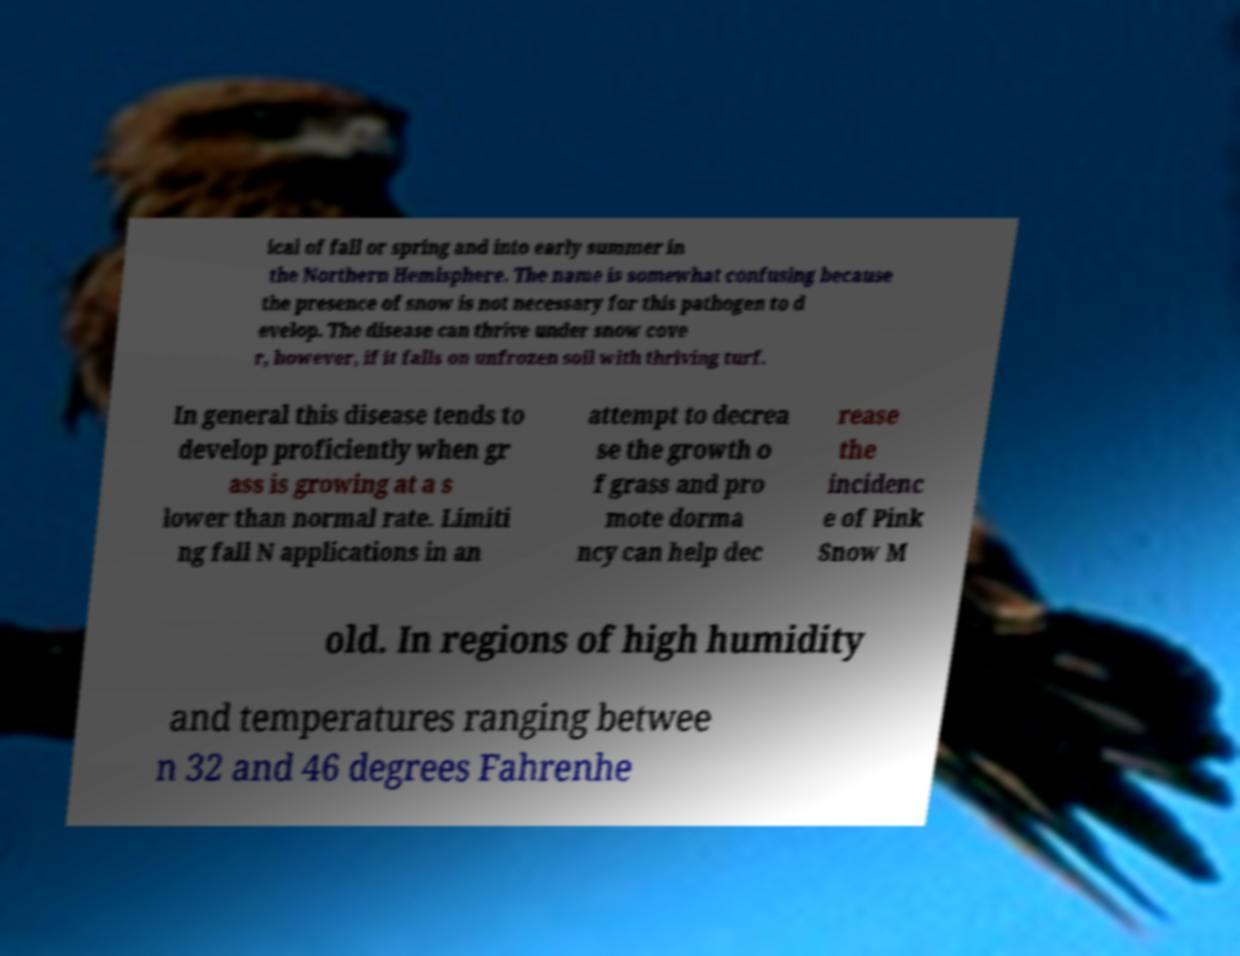There's text embedded in this image that I need extracted. Can you transcribe it verbatim? ical of fall or spring and into early summer in the Northern Hemisphere. The name is somewhat confusing because the presence of snow is not necessary for this pathogen to d evelop. The disease can thrive under snow cove r, however, if it falls on unfrozen soil with thriving turf. In general this disease tends to develop proficiently when gr ass is growing at a s lower than normal rate. Limiti ng fall N applications in an attempt to decrea se the growth o f grass and pro mote dorma ncy can help dec rease the incidenc e of Pink Snow M old. In regions of high humidity and temperatures ranging betwee n 32 and 46 degrees Fahrenhe 